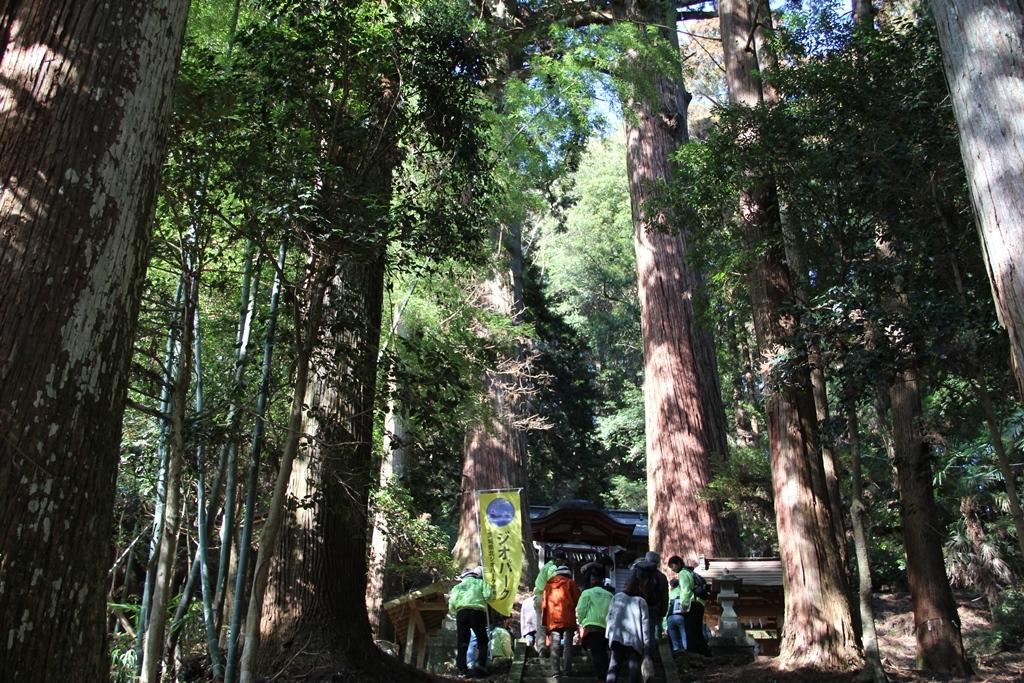Describe this image in one or two sentences. In this picture I can see a group of people are standing. Here I can see a flex banner and a house. In the background I can see trees and the sky. 